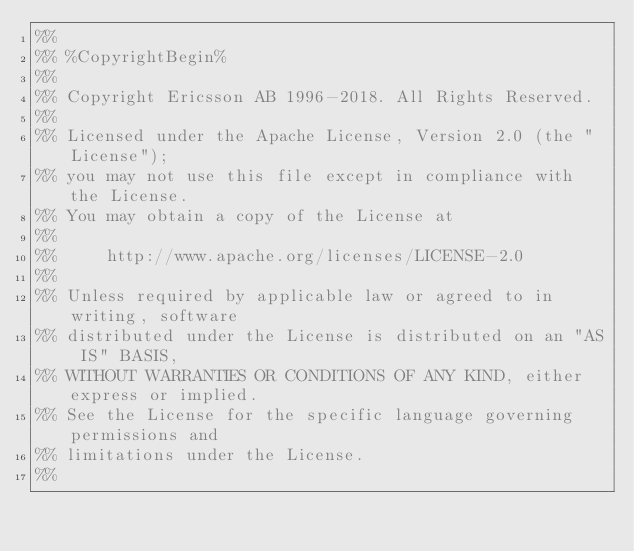<code> <loc_0><loc_0><loc_500><loc_500><_Erlang_>%%
%% %CopyrightBegin%
%%
%% Copyright Ericsson AB 1996-2018. All Rights Reserved.
%%
%% Licensed under the Apache License, Version 2.0 (the "License");
%% you may not use this file except in compliance with the License.
%% You may obtain a copy of the License at
%%
%%     http://www.apache.org/licenses/LICENSE-2.0
%%
%% Unless required by applicable law or agreed to in writing, software
%% distributed under the License is distributed on an "AS IS" BASIS,
%% WITHOUT WARRANTIES OR CONDITIONS OF ANY KIND, either express or implied.
%% See the License for the specific language governing permissions and
%% limitations under the License.
%%</code> 